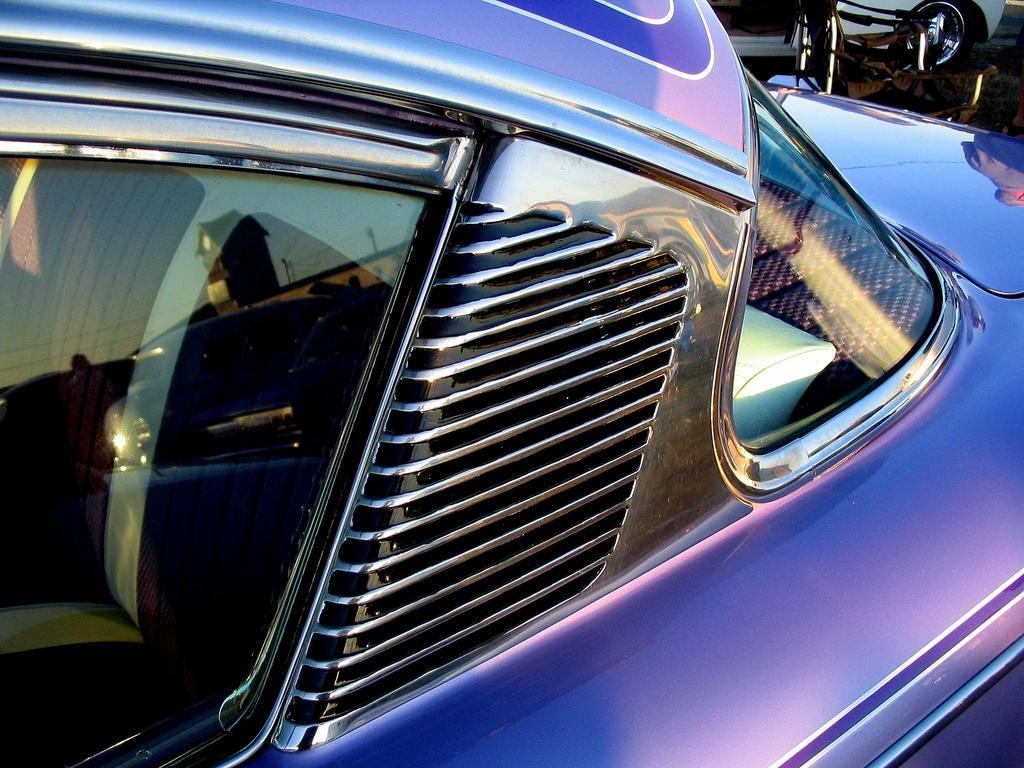Please provide a concise description of this image. In this picture we can see a vehicle which is truncated. On the glass we can see the reflection of a building and sky. 